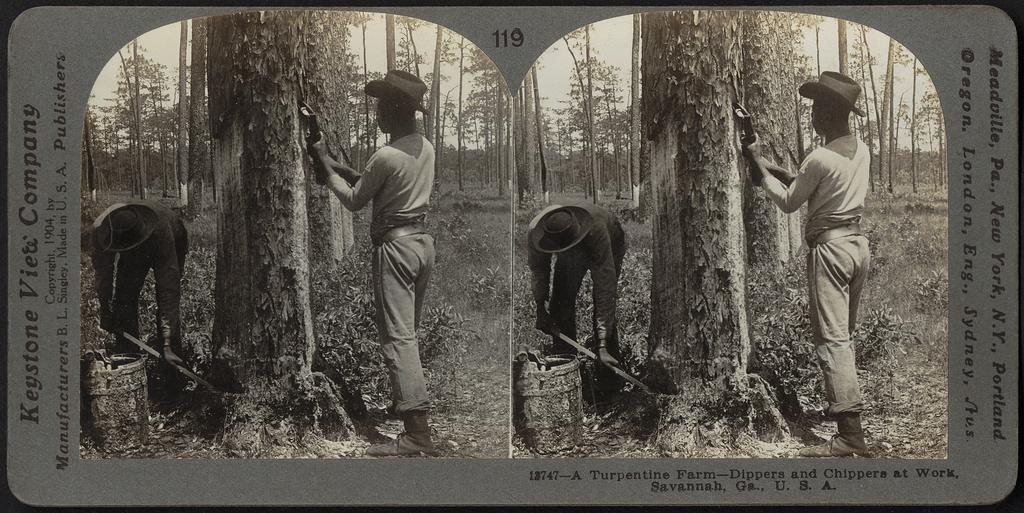What is the main subject of the image? The main subject of the image is a collage of two pictures. How many people are in the collage? There are two people in the collage. What are the people holding in the collage? The people are holding things in the collage. What type of natural elements can be seen in the collage? Trees and plants are visible in the collage. How many trucks can be seen in the collage? There are no trucks visible in the collage; it features two people and natural elements. What type of connection is depicted between the two people in the collage? The image does not show a connection between the two people; it only shows them holding things. 